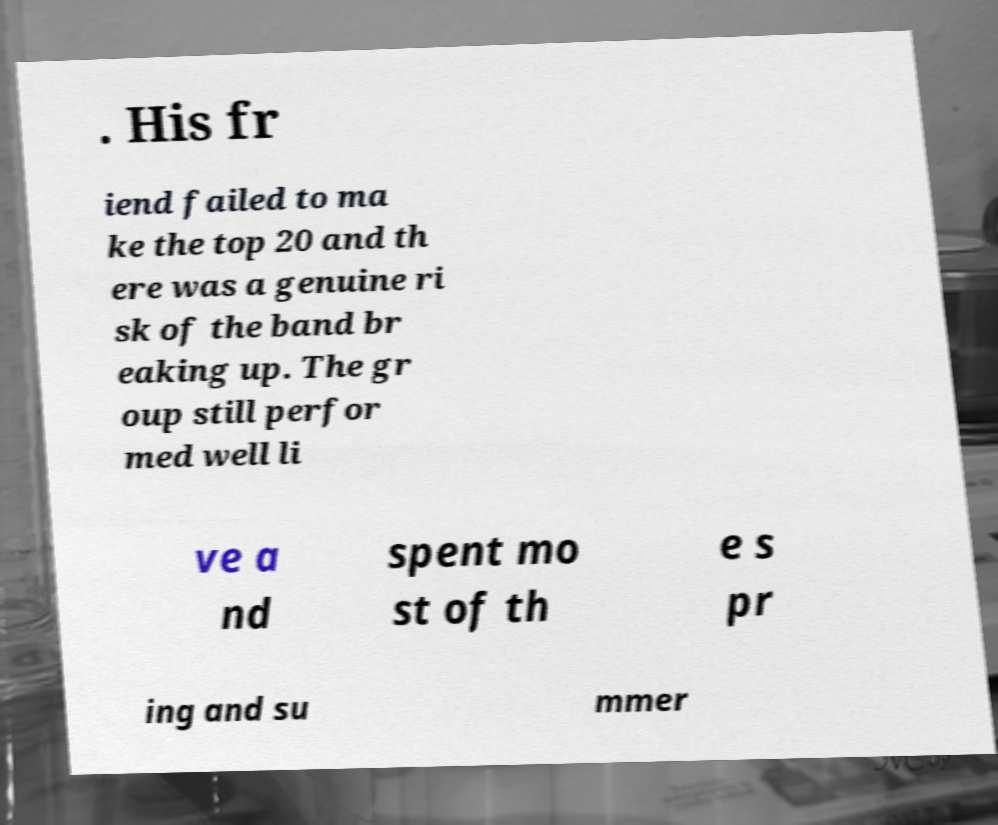Could you assist in decoding the text presented in this image and type it out clearly? . His fr iend failed to ma ke the top 20 and th ere was a genuine ri sk of the band br eaking up. The gr oup still perfor med well li ve a nd spent mo st of th e s pr ing and su mmer 